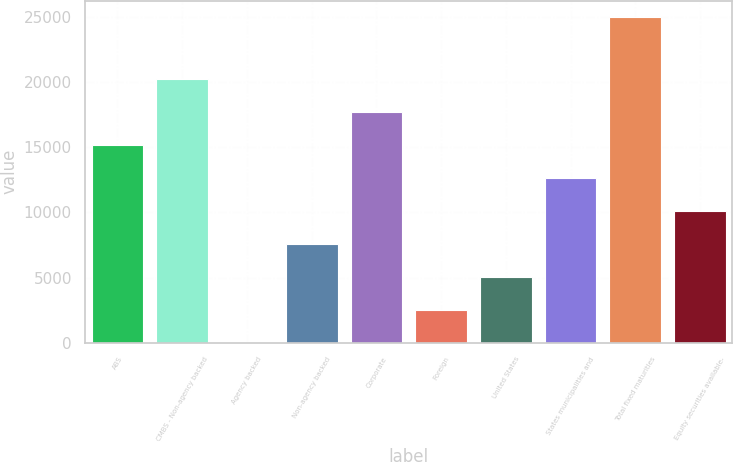Convert chart. <chart><loc_0><loc_0><loc_500><loc_500><bar_chart><fcel>ABS<fcel>CMBS - Non-agency backed<fcel>Agency backed<fcel>Non-agency backed<fcel>Corporate<fcel>Foreign<fcel>United States<fcel>States municipalities and<fcel>Total fixed maturities<fcel>Equity securities available-<nl><fcel>15181<fcel>20230<fcel>34<fcel>7607.5<fcel>17705.5<fcel>2558.5<fcel>5083<fcel>12656.5<fcel>25002<fcel>10132<nl></chart> 